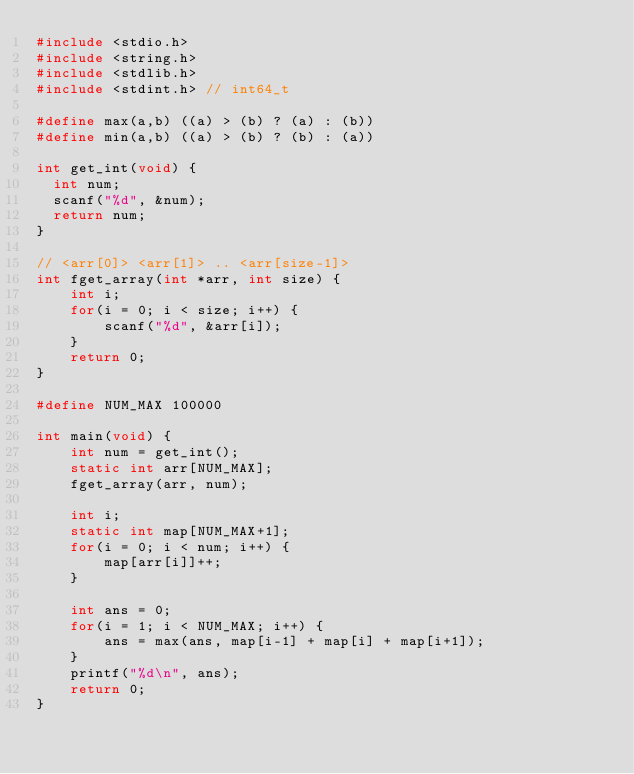<code> <loc_0><loc_0><loc_500><loc_500><_C_>#include <stdio.h>
#include <string.h>
#include <stdlib.h>
#include <stdint.h> // int64_t

#define max(a,b) ((a) > (b) ? (a) : (b))
#define min(a,b) ((a) > (b) ? (b) : (a))

int get_int(void) {
  int num;
  scanf("%d", &num);
  return num;
}

// <arr[0]> <arr[1]> .. <arr[size-1]>
int fget_array(int *arr, int size) {
    int i;
    for(i = 0; i < size; i++) {
        scanf("%d", &arr[i]);
    }
    return 0;
}

#define NUM_MAX 100000

int main(void) {
    int num = get_int();
    static int arr[NUM_MAX];
    fget_array(arr, num);

    int i;
    static int map[NUM_MAX+1];
    for(i = 0; i < num; i++) {
        map[arr[i]]++;
    }

    int ans = 0;
    for(i = 1; i < NUM_MAX; i++) {
        ans = max(ans, map[i-1] + map[i] + map[i+1]);
    }
    printf("%d\n", ans);
    return 0;
}
</code> 